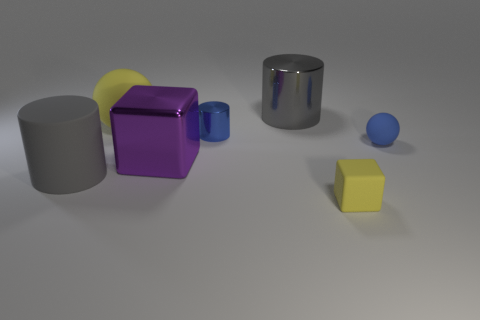How many things are either big gray things or large rubber things in front of the purple metal cube?
Keep it short and to the point. 2. How many big purple blocks are on the left side of the small matte sphere that is right of the large cylinder right of the big purple metallic block?
Your answer should be compact. 1. There is a cylinder that is the same size as the gray rubber thing; what is it made of?
Ensure brevity in your answer.  Metal. Is there a brown shiny sphere of the same size as the purple thing?
Make the answer very short. No. What is the color of the large ball?
Give a very brief answer. Yellow. What color is the big matte thing on the right side of the gray thing on the left side of the blue metal cylinder?
Provide a succinct answer. Yellow. The matte object behind the rubber ball that is to the right of the thing behind the big rubber sphere is what shape?
Give a very brief answer. Sphere. How many blue cylinders are the same material as the tiny yellow thing?
Your answer should be compact. 0. There is a big rubber object in front of the tiny matte sphere; how many yellow rubber things are in front of it?
Offer a very short reply. 1. What number of blue metallic objects are there?
Give a very brief answer. 1. 